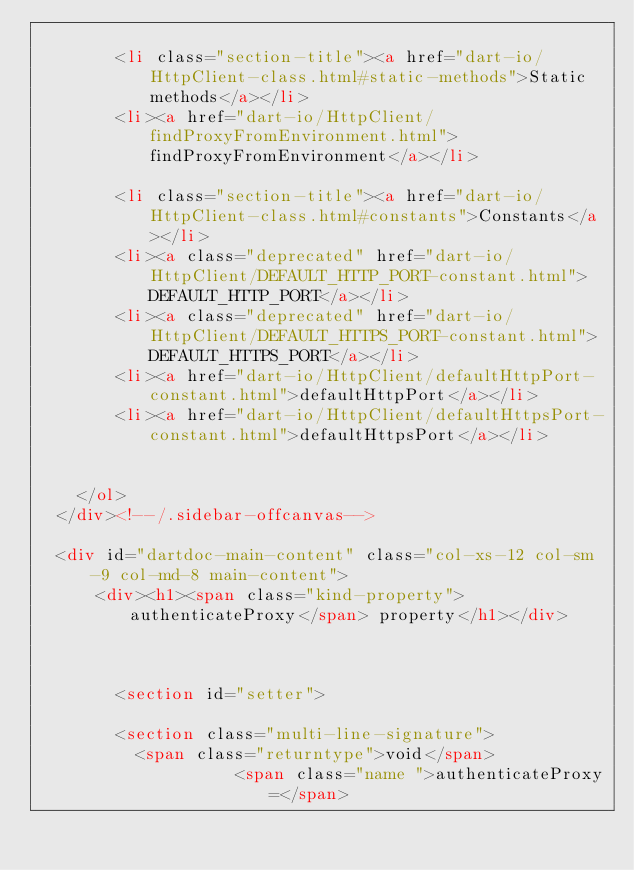Convert code to text. <code><loc_0><loc_0><loc_500><loc_500><_HTML_>    
        <li class="section-title"><a href="dart-io/HttpClient-class.html#static-methods">Static methods</a></li>
        <li><a href="dart-io/HttpClient/findProxyFromEnvironment.html">findProxyFromEnvironment</a></li>
    
        <li class="section-title"><a href="dart-io/HttpClient-class.html#constants">Constants</a></li>
        <li><a class="deprecated" href="dart-io/HttpClient/DEFAULT_HTTP_PORT-constant.html">DEFAULT_HTTP_PORT</a></li>
        <li><a class="deprecated" href="dart-io/HttpClient/DEFAULT_HTTPS_PORT-constant.html">DEFAULT_HTTPS_PORT</a></li>
        <li><a href="dart-io/HttpClient/defaultHttpPort-constant.html">defaultHttpPort</a></li>
        <li><a href="dart-io/HttpClient/defaultHttpsPort-constant.html">defaultHttpsPort</a></li>
    
    
    </ol>
  </div><!--/.sidebar-offcanvas-->

  <div id="dartdoc-main-content" class="col-xs-12 col-sm-9 col-md-8 main-content">
      <div><h1><span class="kind-property">authenticateProxy</span> property</h1></div>



        <section id="setter">
        
        <section class="multi-line-signature">
          <span class="returntype">void</span>
                    <span class="name ">authenticateProxy=</span></code> 